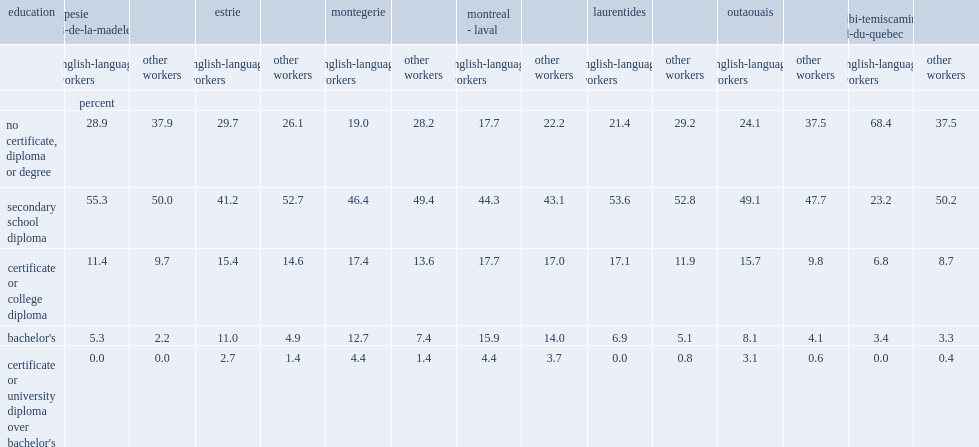List regions in which english-language workers were more likely to have no certificate, diploma or degree, and less likely to have a high school diploma. Estrie abitibi-temiscamingue nord-du-quebec. 